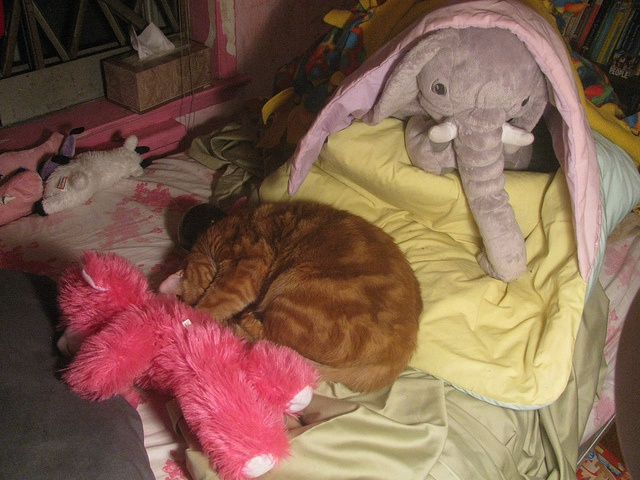Describe the objects in this image and their specific colors. I can see teddy bear in maroon, salmon, and brown tones, cat in maroon, brown, and black tones, bed in maroon, gray, and black tones, book in maroon, black, and darkgreen tones, and book in maroon and black tones in this image. 